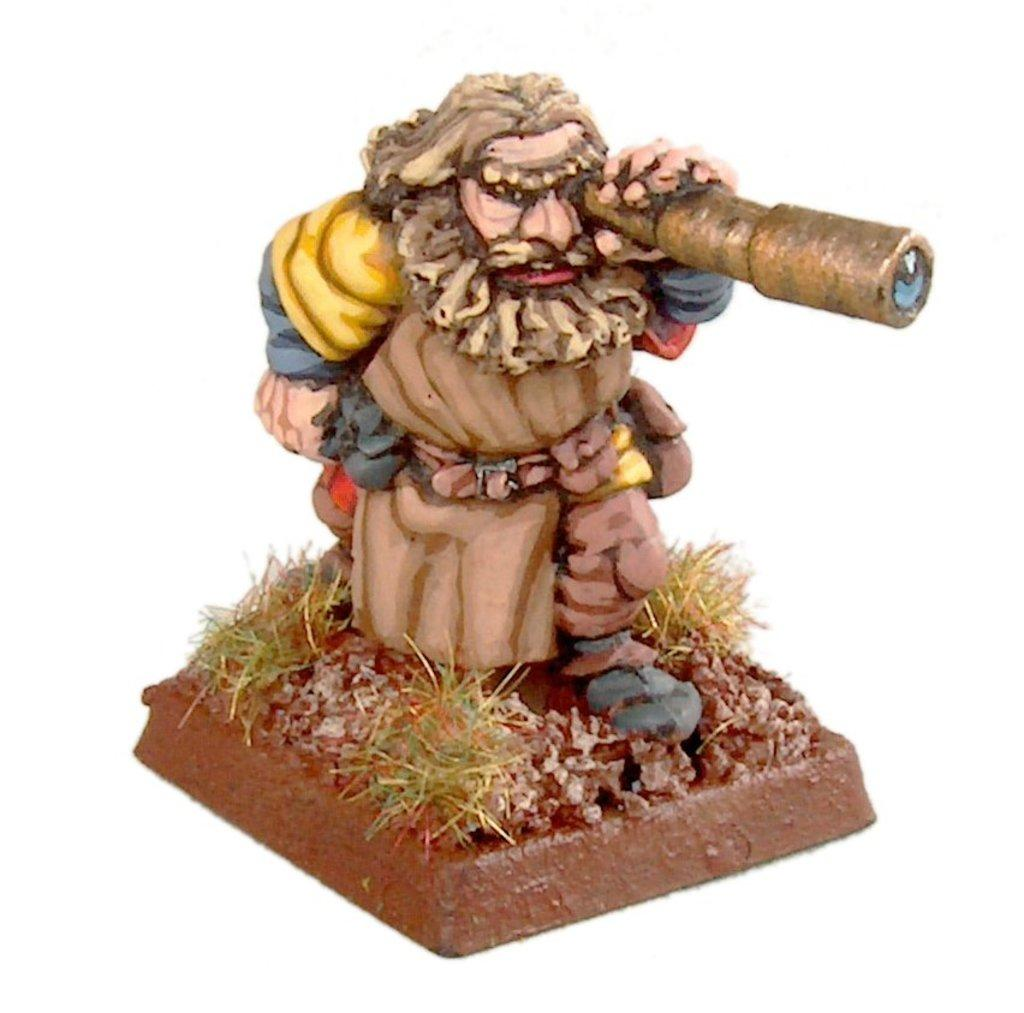What is the main subject of the image? There is a depiction of a man in the image. What type of bun is the man holding in the image? There is no bun present in the image; it only depicts a man. How does the man grip the plate in the image? There is no plate present in the image, so it is not possible to determine how the man grips it. 